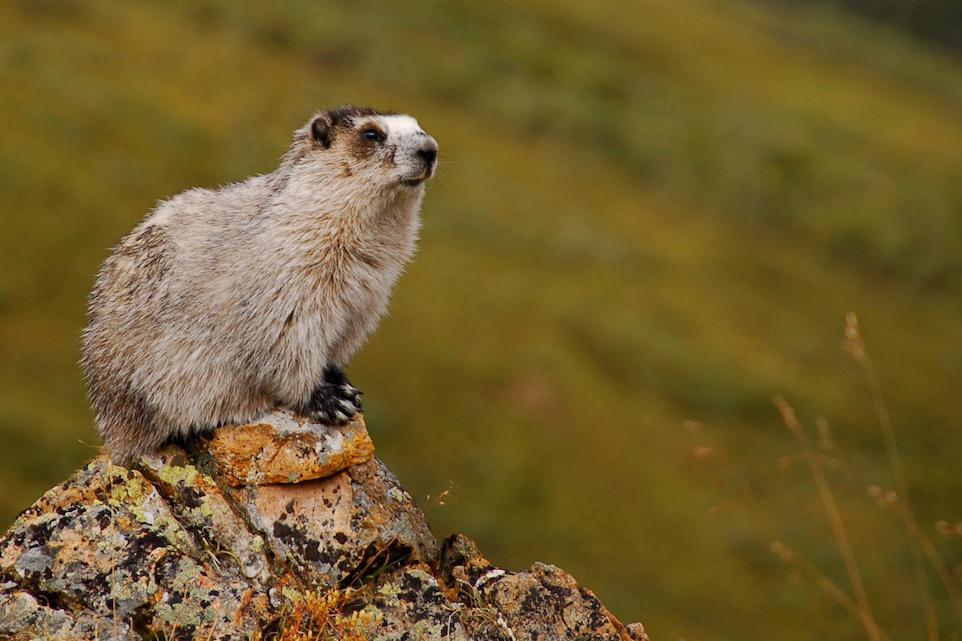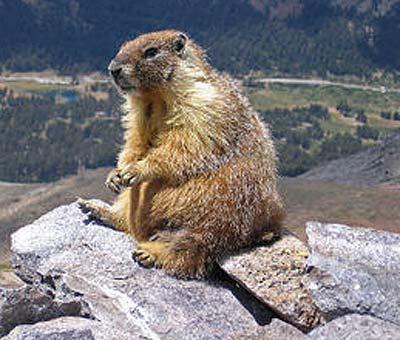The first image is the image on the left, the second image is the image on the right. For the images shown, is this caption "There are two ground hogs perched high on a rock." true? Answer yes or no. Yes. The first image is the image on the left, the second image is the image on the right. Analyze the images presented: Is the assertion "One of the groundhogs is near yellow flowers." valid? Answer yes or no. No. 